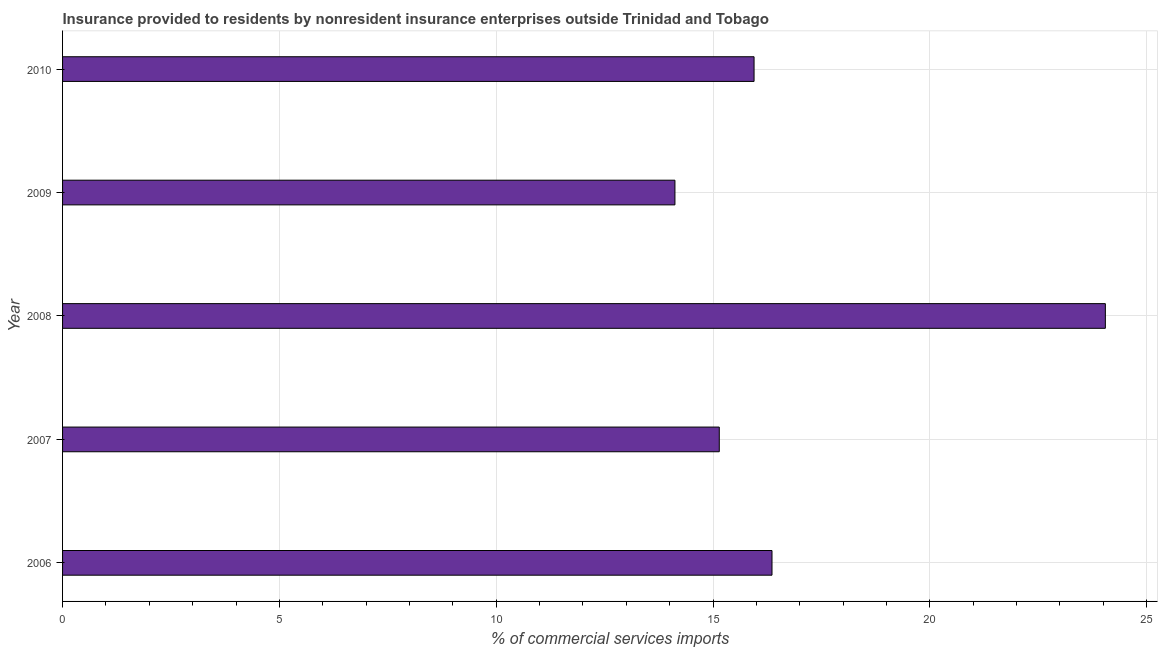What is the title of the graph?
Your response must be concise. Insurance provided to residents by nonresident insurance enterprises outside Trinidad and Tobago. What is the label or title of the X-axis?
Your response must be concise. % of commercial services imports. What is the label or title of the Y-axis?
Provide a succinct answer. Year. What is the insurance provided by non-residents in 2010?
Offer a very short reply. 15.95. Across all years, what is the maximum insurance provided by non-residents?
Provide a succinct answer. 24.05. Across all years, what is the minimum insurance provided by non-residents?
Make the answer very short. 14.12. What is the sum of the insurance provided by non-residents?
Your answer should be very brief. 85.62. What is the difference between the insurance provided by non-residents in 2006 and 2008?
Keep it short and to the point. -7.69. What is the average insurance provided by non-residents per year?
Your answer should be compact. 17.12. What is the median insurance provided by non-residents?
Your answer should be very brief. 15.95. Do a majority of the years between 2006 and 2010 (inclusive) have insurance provided by non-residents greater than 18 %?
Make the answer very short. No. What is the ratio of the insurance provided by non-residents in 2006 to that in 2008?
Offer a terse response. 0.68. Is the insurance provided by non-residents in 2006 less than that in 2008?
Your response must be concise. Yes. Is the difference between the insurance provided by non-residents in 2006 and 2010 greater than the difference between any two years?
Provide a short and direct response. No. What is the difference between the highest and the second highest insurance provided by non-residents?
Your response must be concise. 7.69. Is the sum of the insurance provided by non-residents in 2006 and 2010 greater than the maximum insurance provided by non-residents across all years?
Ensure brevity in your answer.  Yes. What is the difference between the highest and the lowest insurance provided by non-residents?
Ensure brevity in your answer.  9.93. How many bars are there?
Provide a succinct answer. 5. Are all the bars in the graph horizontal?
Make the answer very short. Yes. What is the % of commercial services imports of 2006?
Your response must be concise. 16.36. What is the % of commercial services imports of 2007?
Your answer should be very brief. 15.14. What is the % of commercial services imports of 2008?
Offer a very short reply. 24.05. What is the % of commercial services imports of 2009?
Your response must be concise. 14.12. What is the % of commercial services imports of 2010?
Provide a succinct answer. 15.95. What is the difference between the % of commercial services imports in 2006 and 2007?
Your answer should be compact. 1.22. What is the difference between the % of commercial services imports in 2006 and 2008?
Give a very brief answer. -7.69. What is the difference between the % of commercial services imports in 2006 and 2009?
Make the answer very short. 2.24. What is the difference between the % of commercial services imports in 2006 and 2010?
Offer a very short reply. 0.41. What is the difference between the % of commercial services imports in 2007 and 2008?
Provide a short and direct response. -8.9. What is the difference between the % of commercial services imports in 2007 and 2009?
Keep it short and to the point. 1.02. What is the difference between the % of commercial services imports in 2007 and 2010?
Ensure brevity in your answer.  -0.8. What is the difference between the % of commercial services imports in 2008 and 2009?
Your answer should be very brief. 9.93. What is the difference between the % of commercial services imports in 2008 and 2010?
Keep it short and to the point. 8.1. What is the difference between the % of commercial services imports in 2009 and 2010?
Offer a terse response. -1.82. What is the ratio of the % of commercial services imports in 2006 to that in 2007?
Give a very brief answer. 1.08. What is the ratio of the % of commercial services imports in 2006 to that in 2008?
Your response must be concise. 0.68. What is the ratio of the % of commercial services imports in 2006 to that in 2009?
Give a very brief answer. 1.16. What is the ratio of the % of commercial services imports in 2006 to that in 2010?
Make the answer very short. 1.03. What is the ratio of the % of commercial services imports in 2007 to that in 2008?
Provide a short and direct response. 0.63. What is the ratio of the % of commercial services imports in 2007 to that in 2009?
Ensure brevity in your answer.  1.07. What is the ratio of the % of commercial services imports in 2007 to that in 2010?
Make the answer very short. 0.95. What is the ratio of the % of commercial services imports in 2008 to that in 2009?
Your answer should be compact. 1.7. What is the ratio of the % of commercial services imports in 2008 to that in 2010?
Your response must be concise. 1.51. What is the ratio of the % of commercial services imports in 2009 to that in 2010?
Offer a terse response. 0.89. 